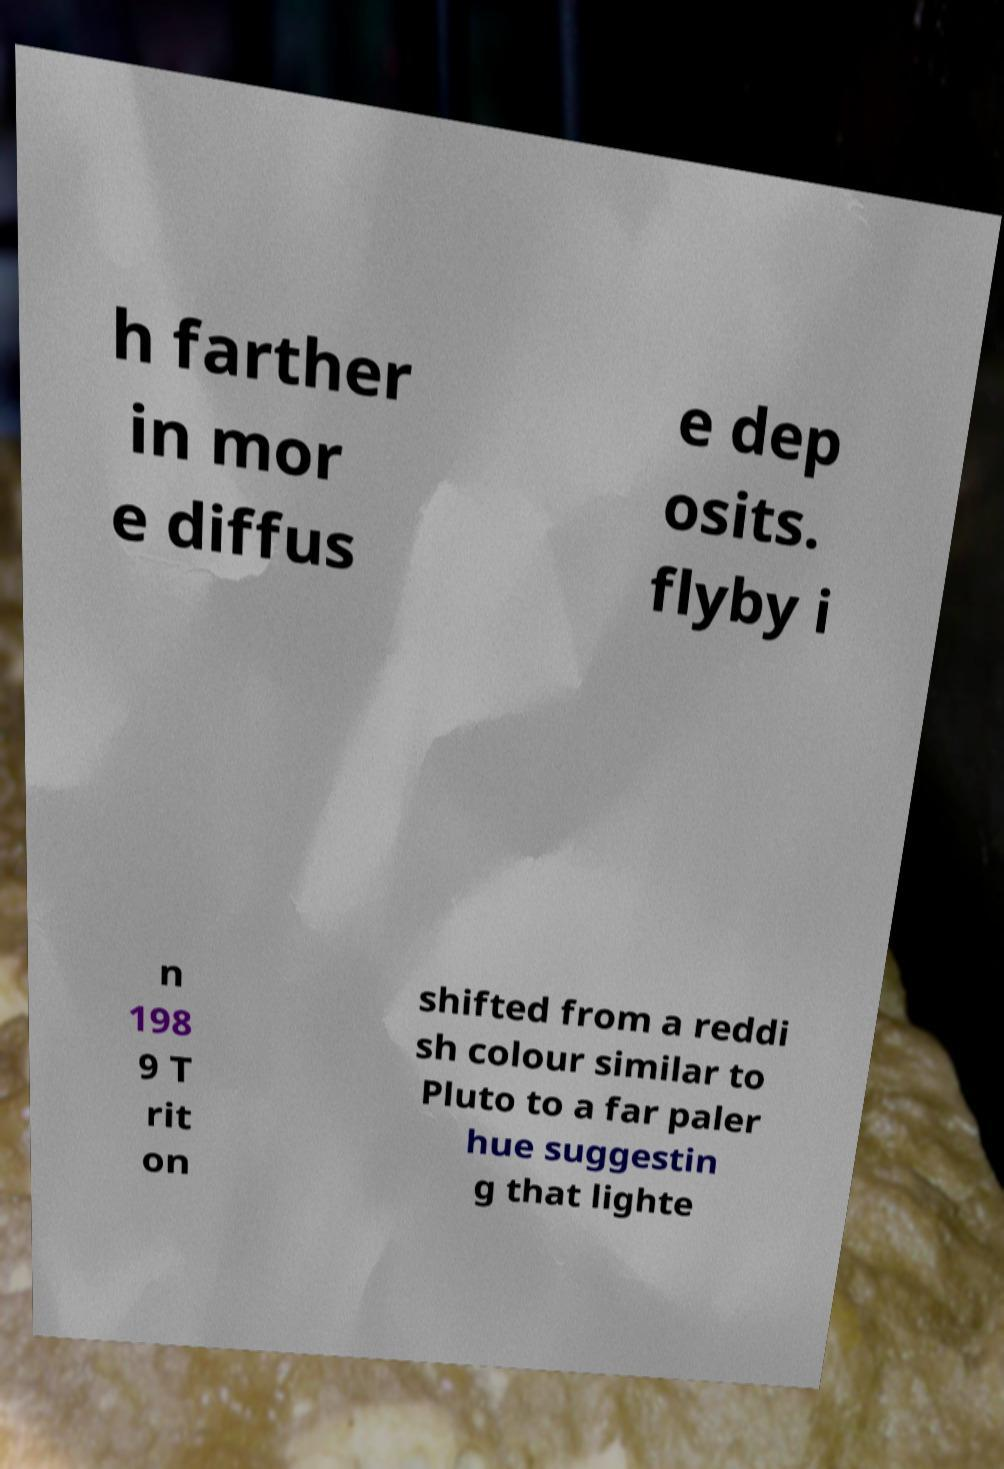I need the written content from this picture converted into text. Can you do that? h farther in mor e diffus e dep osits. flyby i n 198 9 T rit on shifted from a reddi sh colour similar to Pluto to a far paler hue suggestin g that lighte 